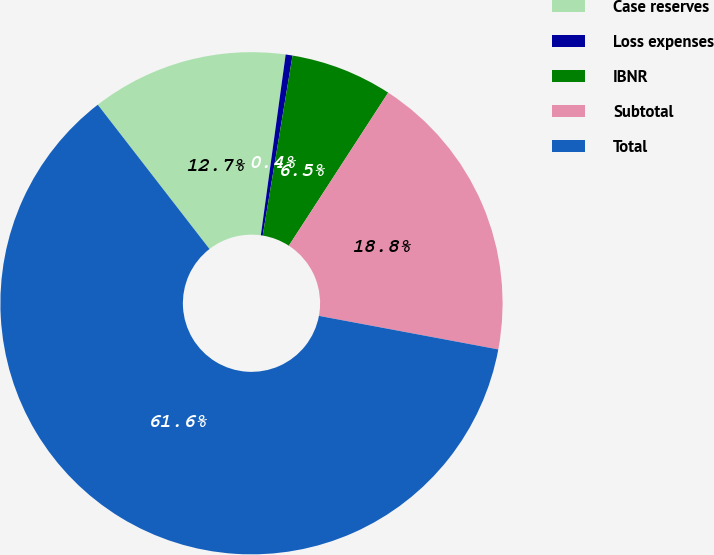Convert chart. <chart><loc_0><loc_0><loc_500><loc_500><pie_chart><fcel>Case reserves<fcel>Loss expenses<fcel>IBNR<fcel>Subtotal<fcel>Total<nl><fcel>12.66%<fcel>0.44%<fcel>6.55%<fcel>18.78%<fcel>61.57%<nl></chart> 